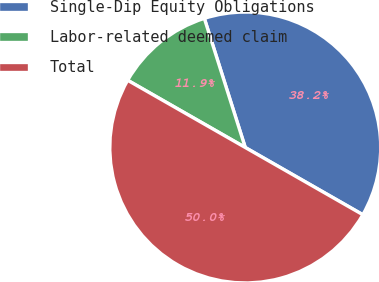Convert chart. <chart><loc_0><loc_0><loc_500><loc_500><pie_chart><fcel>Single-Dip Equity Obligations<fcel>Labor-related deemed claim<fcel>Total<nl><fcel>38.15%<fcel>11.85%<fcel>50.0%<nl></chart> 